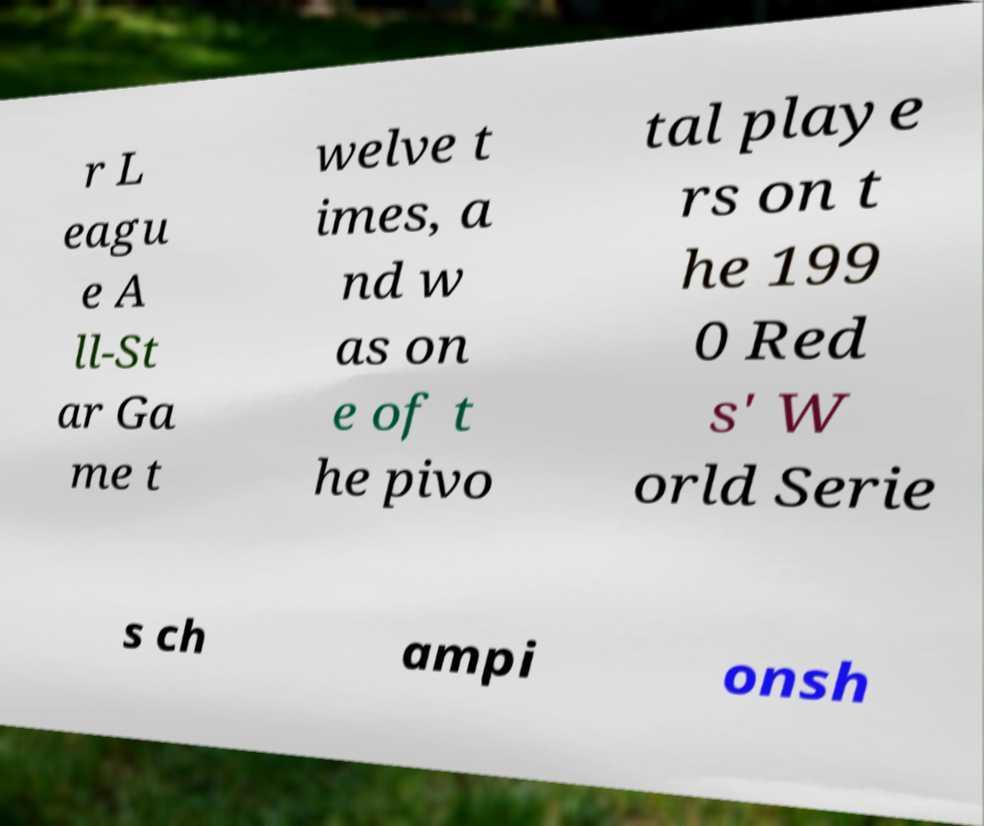There's text embedded in this image that I need extracted. Can you transcribe it verbatim? r L eagu e A ll-St ar Ga me t welve t imes, a nd w as on e of t he pivo tal playe rs on t he 199 0 Red s' W orld Serie s ch ampi onsh 